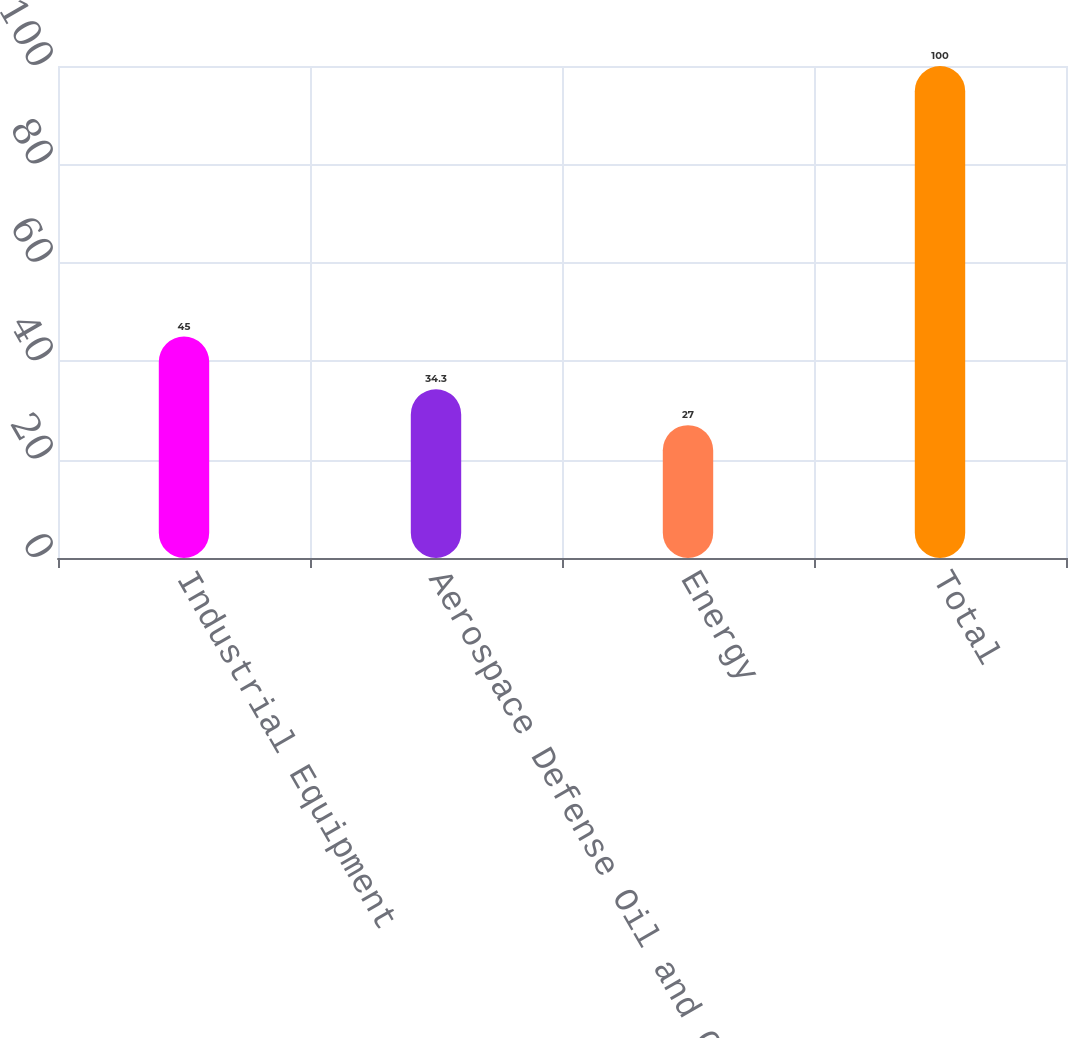<chart> <loc_0><loc_0><loc_500><loc_500><bar_chart><fcel>Industrial Equipment<fcel>Aerospace Defense Oil and Gas<fcel>Energy<fcel>Total<nl><fcel>45<fcel>34.3<fcel>27<fcel>100<nl></chart> 